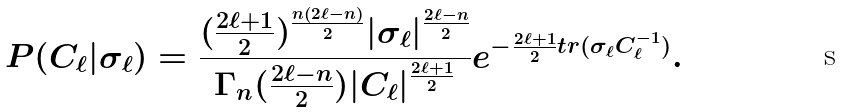<formula> <loc_0><loc_0><loc_500><loc_500>P ( C _ { \ell } | \sigma _ { \ell } ) = \frac { ( \frac { 2 \ell + 1 } { 2 } ) ^ { \frac { n ( 2 \ell - n ) } { 2 } } | \sigma _ { \ell } | ^ { \frac { 2 \ell - n } { 2 } } } { \Gamma _ { n } ( \frac { 2 \ell - n } { 2 } ) | C _ { \ell } | ^ { \frac { 2 \ell + 1 } { 2 } } } e ^ { - \frac { 2 \ell + 1 } { 2 } t r ( \sigma _ { \ell } C ^ { - 1 } _ { \ell } ) } .</formula> 